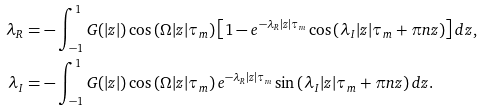Convert formula to latex. <formula><loc_0><loc_0><loc_500><loc_500>\lambda _ { R } & = - \int _ { - 1 } ^ { 1 } G ( | z | ) \cos \left ( \Omega | z | \tau _ { m } \right ) \left [ 1 - e ^ { - \lambda _ { R } | z | \tau _ { m } } \cos \left ( \lambda _ { I } | z | \tau _ { m } + \pi n z \right ) \right ] d z , \\ \lambda _ { I } & = - \int _ { - 1 } ^ { 1 } G ( | z | ) \cos \left ( \Omega | z | \tau _ { m } \right ) e ^ { - \lambda _ { R } | z | \tau _ { m } } \sin \left ( \lambda _ { I } | z | \tau _ { m } + \pi n z \right ) d z .</formula> 